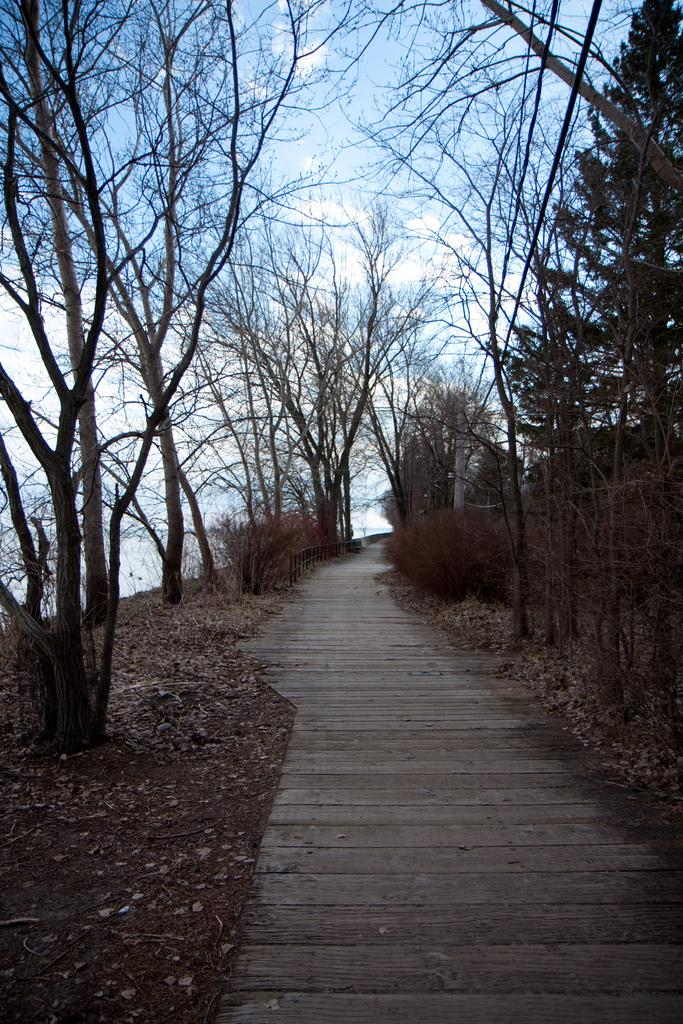What type of vegetation can be seen in the image? There are trees and plants in the image. What kind of path is present in the image? There is a wooden path in the image. What is visible in the background of the image? The sky is visible in the image. How would you describe the sky in the image? The sky appears to be cloudy in the image. Can you tell me where your uncle is pushing the notebook in the image? There is no uncle or notebook present in the image. 